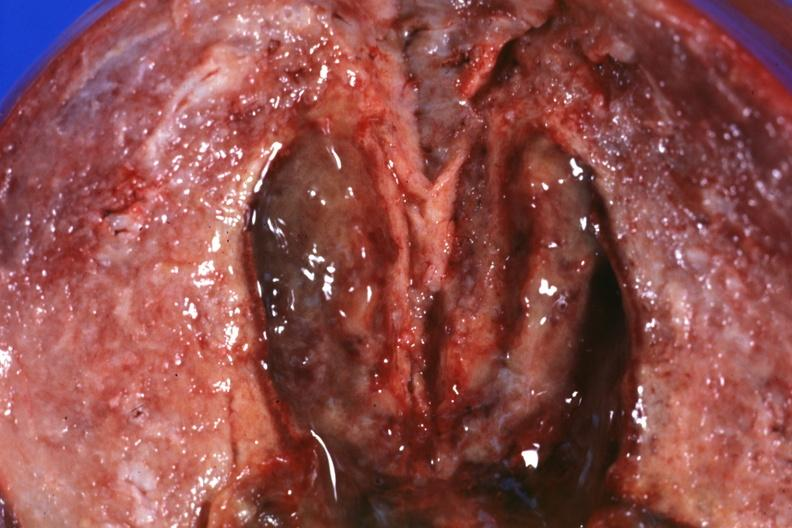where does this part belong to?
Answer the question using a single word or phrase. Female reproductive system 